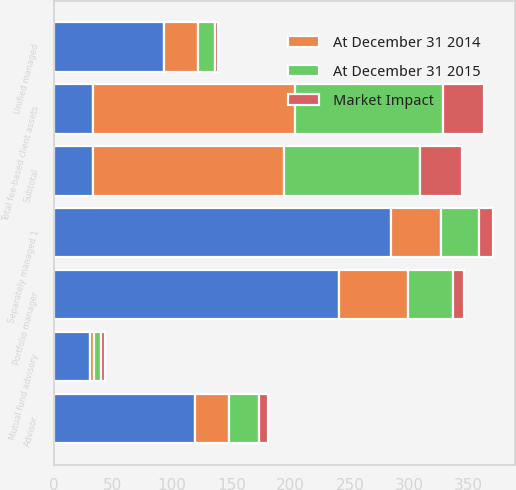Convert chart to OTSL. <chart><loc_0><loc_0><loc_500><loc_500><stacked_bar_chart><ecel><fcel>Separately managed 1<fcel>Unified managed<fcel>Mutual fund advisory<fcel>Advisor<fcel>Portfolio manager<fcel>Subtotal<fcel>Total fee-based client assets<nl><fcel>nan<fcel>285<fcel>93<fcel>31<fcel>119<fcel>241<fcel>33.5<fcel>33.5<nl><fcel>At December 31 2014<fcel>42<fcel>29<fcel>3<fcel>29<fcel>58<fcel>161<fcel>170<nl><fcel>At December 31 2015<fcel>32<fcel>14<fcel>6<fcel>25<fcel>38<fcel>115<fcel>125<nl><fcel>Market Impact<fcel>12<fcel>3<fcel>3<fcel>8<fcel>9<fcel>35<fcel>35<nl></chart> 